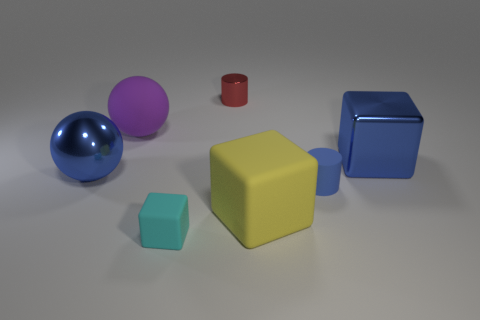Are there any cylinders to the left of the yellow object?
Offer a terse response. Yes. Are there an equal number of blue metallic things that are on the right side of the cyan object and large red rubber cylinders?
Provide a short and direct response. No. There is a tiny cylinder that is behind the block right of the small matte cylinder; is there a small cyan cube right of it?
Offer a terse response. No. What material is the small blue object?
Your answer should be very brief. Rubber. How many other objects are the same shape as the yellow matte thing?
Provide a succinct answer. 2. Is the cyan object the same shape as the yellow object?
Your answer should be very brief. Yes. How many things are either rubber objects that are behind the tiny cyan matte object or big blue metal objects that are right of the tiny blue rubber cylinder?
Your response must be concise. 4. What number of things are rubber blocks or shiny cylinders?
Provide a succinct answer. 3. How many blue spheres are behind the block that is behind the small blue object?
Your response must be concise. 0. How many other objects are the same size as the yellow block?
Your response must be concise. 3. 